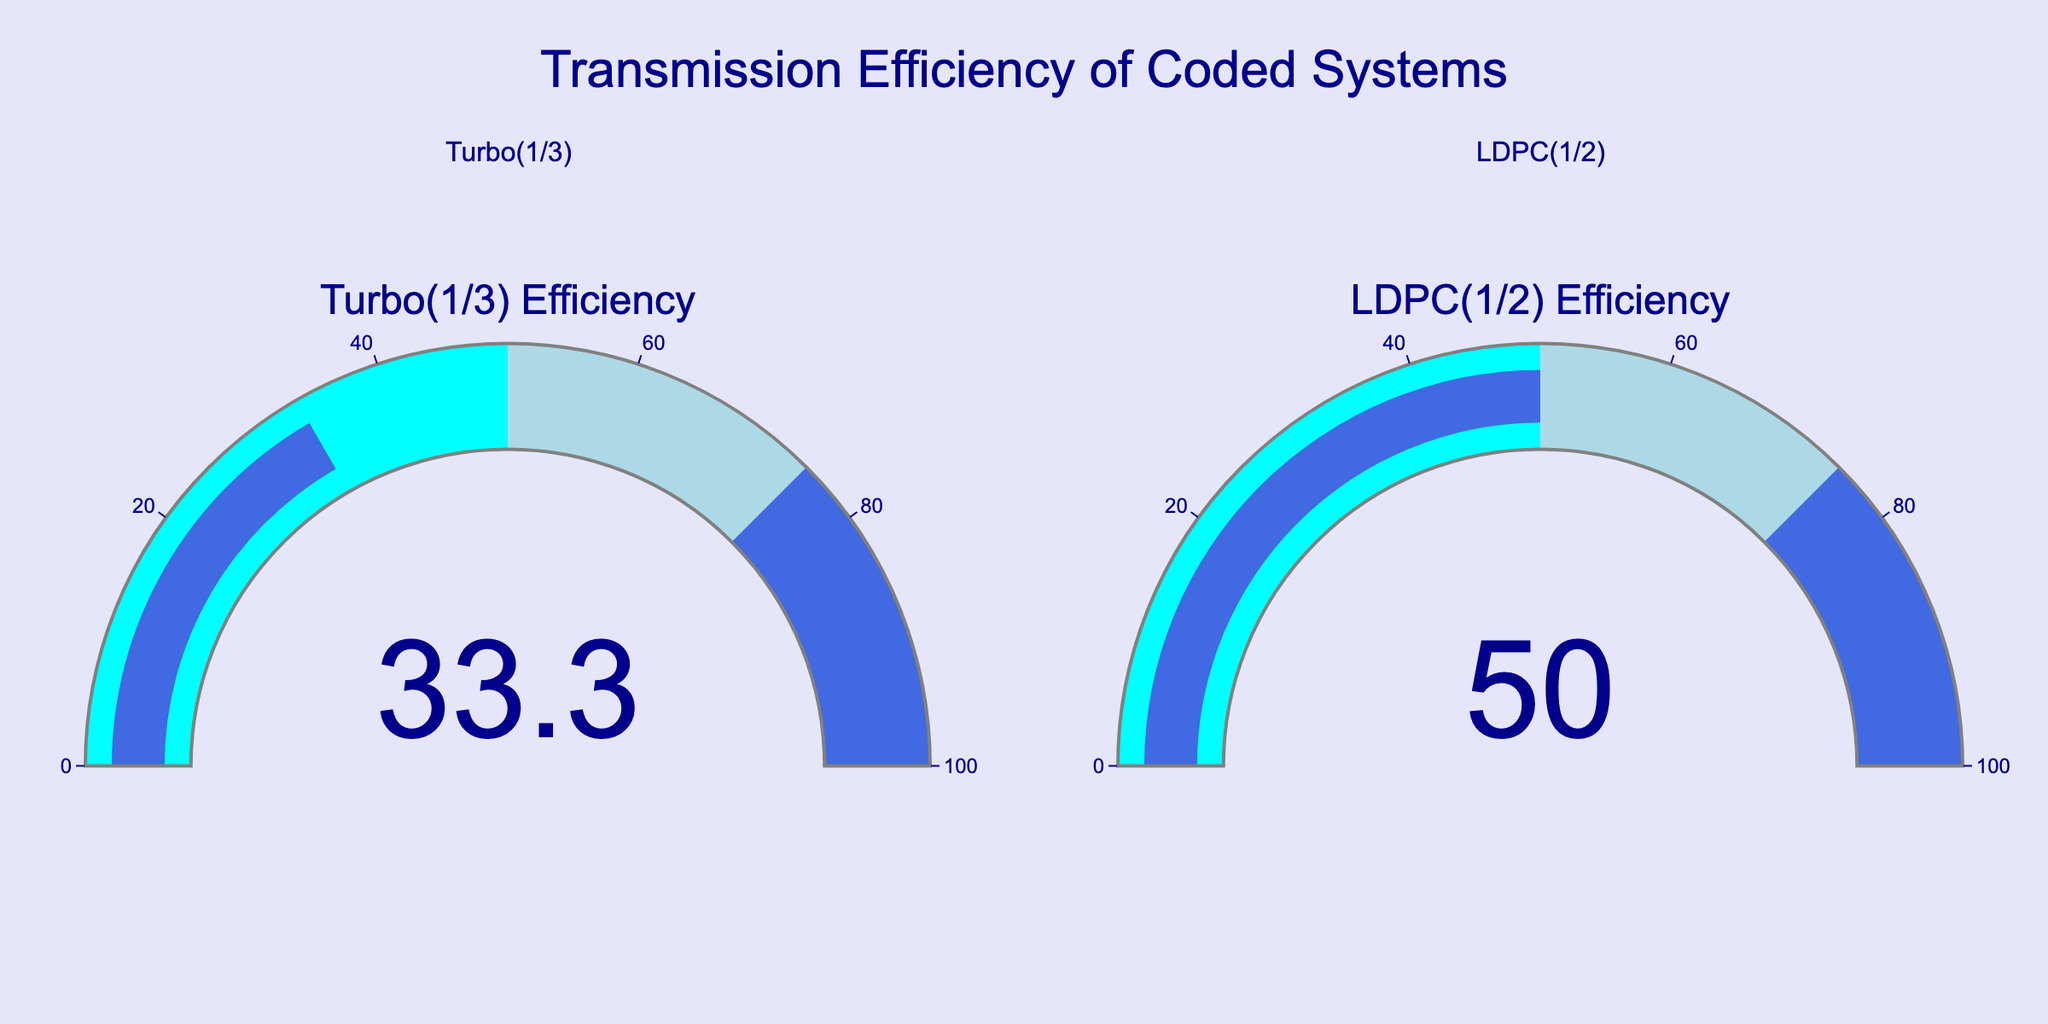What's the title of the figure? The title of the figure is located at the top center and reads "Transmission Efficiency of Coded Systems".
Answer: Transmission Efficiency of Coded Systems What values are shown on the gauges for Turbo(1/3) and LDPC(1/2)? The values displayed in the gauges for Turbo(1/3) and LDPC(1/2) are 33.3 and 50.0, respectively.
Answer: 33.3 and 50.0 Which coded system has higher transmission efficiency, Turbo(1/3) or LDPC(1/2)? Comparing the values displayed on the gauges, LDPC(1/2) has a higher transmission efficiency (50.0) compared to Turbo(1/3) (33.3).
Answer: LDPC(1/2) How much higher is the efficiency of LDPC(1/2) compared to Turbo(1/3)? To find how much higher the efficiency of LDPC(1/2) is compared to Turbo(1/3), subtract the efficiency of Turbo(1/3) from the efficiency of LDPC(1/2): 50.0 - 33.3 = 16.7.
Answer: 16.7 What is the color transition for the efficiency range on each gauge? The efficiency range on each gauge transitions from cyan (0-50), to lightblue (50-75), and finally to royalblue (75-100).
Answer: cyan, lightblue, royalblue What is the overall efficiency range displayed on the gauges? The overall efficiency range displayed is from 0 to 100, as indicated by the range of the axis on the gauges.
Answer: 0 to 100 In what color range is the Turbo(1/3) efficiency value located? The Turbo(1/3) efficiency value of 33.3 is located in the cyan color range, which represents 0-50.
Answer: cyan How is the background of each gauge designed? The background of each gauge is white, with a gray border, and a bar colored royalblue.
Answer: white with gray border and royalblue bar What is the difference between the minimum and the maximum efficiency values displayed in the figure? The minimum efficiency value displayed is 33.3 (for Turbo(1/3)), and the maximum is 50.0 (for LDPC(1/2)). The difference can be calculated as 50.0 - 33.3 = 16.7.
Answer: 16.7 Which gauge shows a color transition from cyan to lightblue? The gauge displaying the efficiency of LDPC(1/2) (50.0) shows a transition from cyan to lightblue, as 50.0 falls within the range of lightblue (50-75).
Answer: LDPC(1/2) 